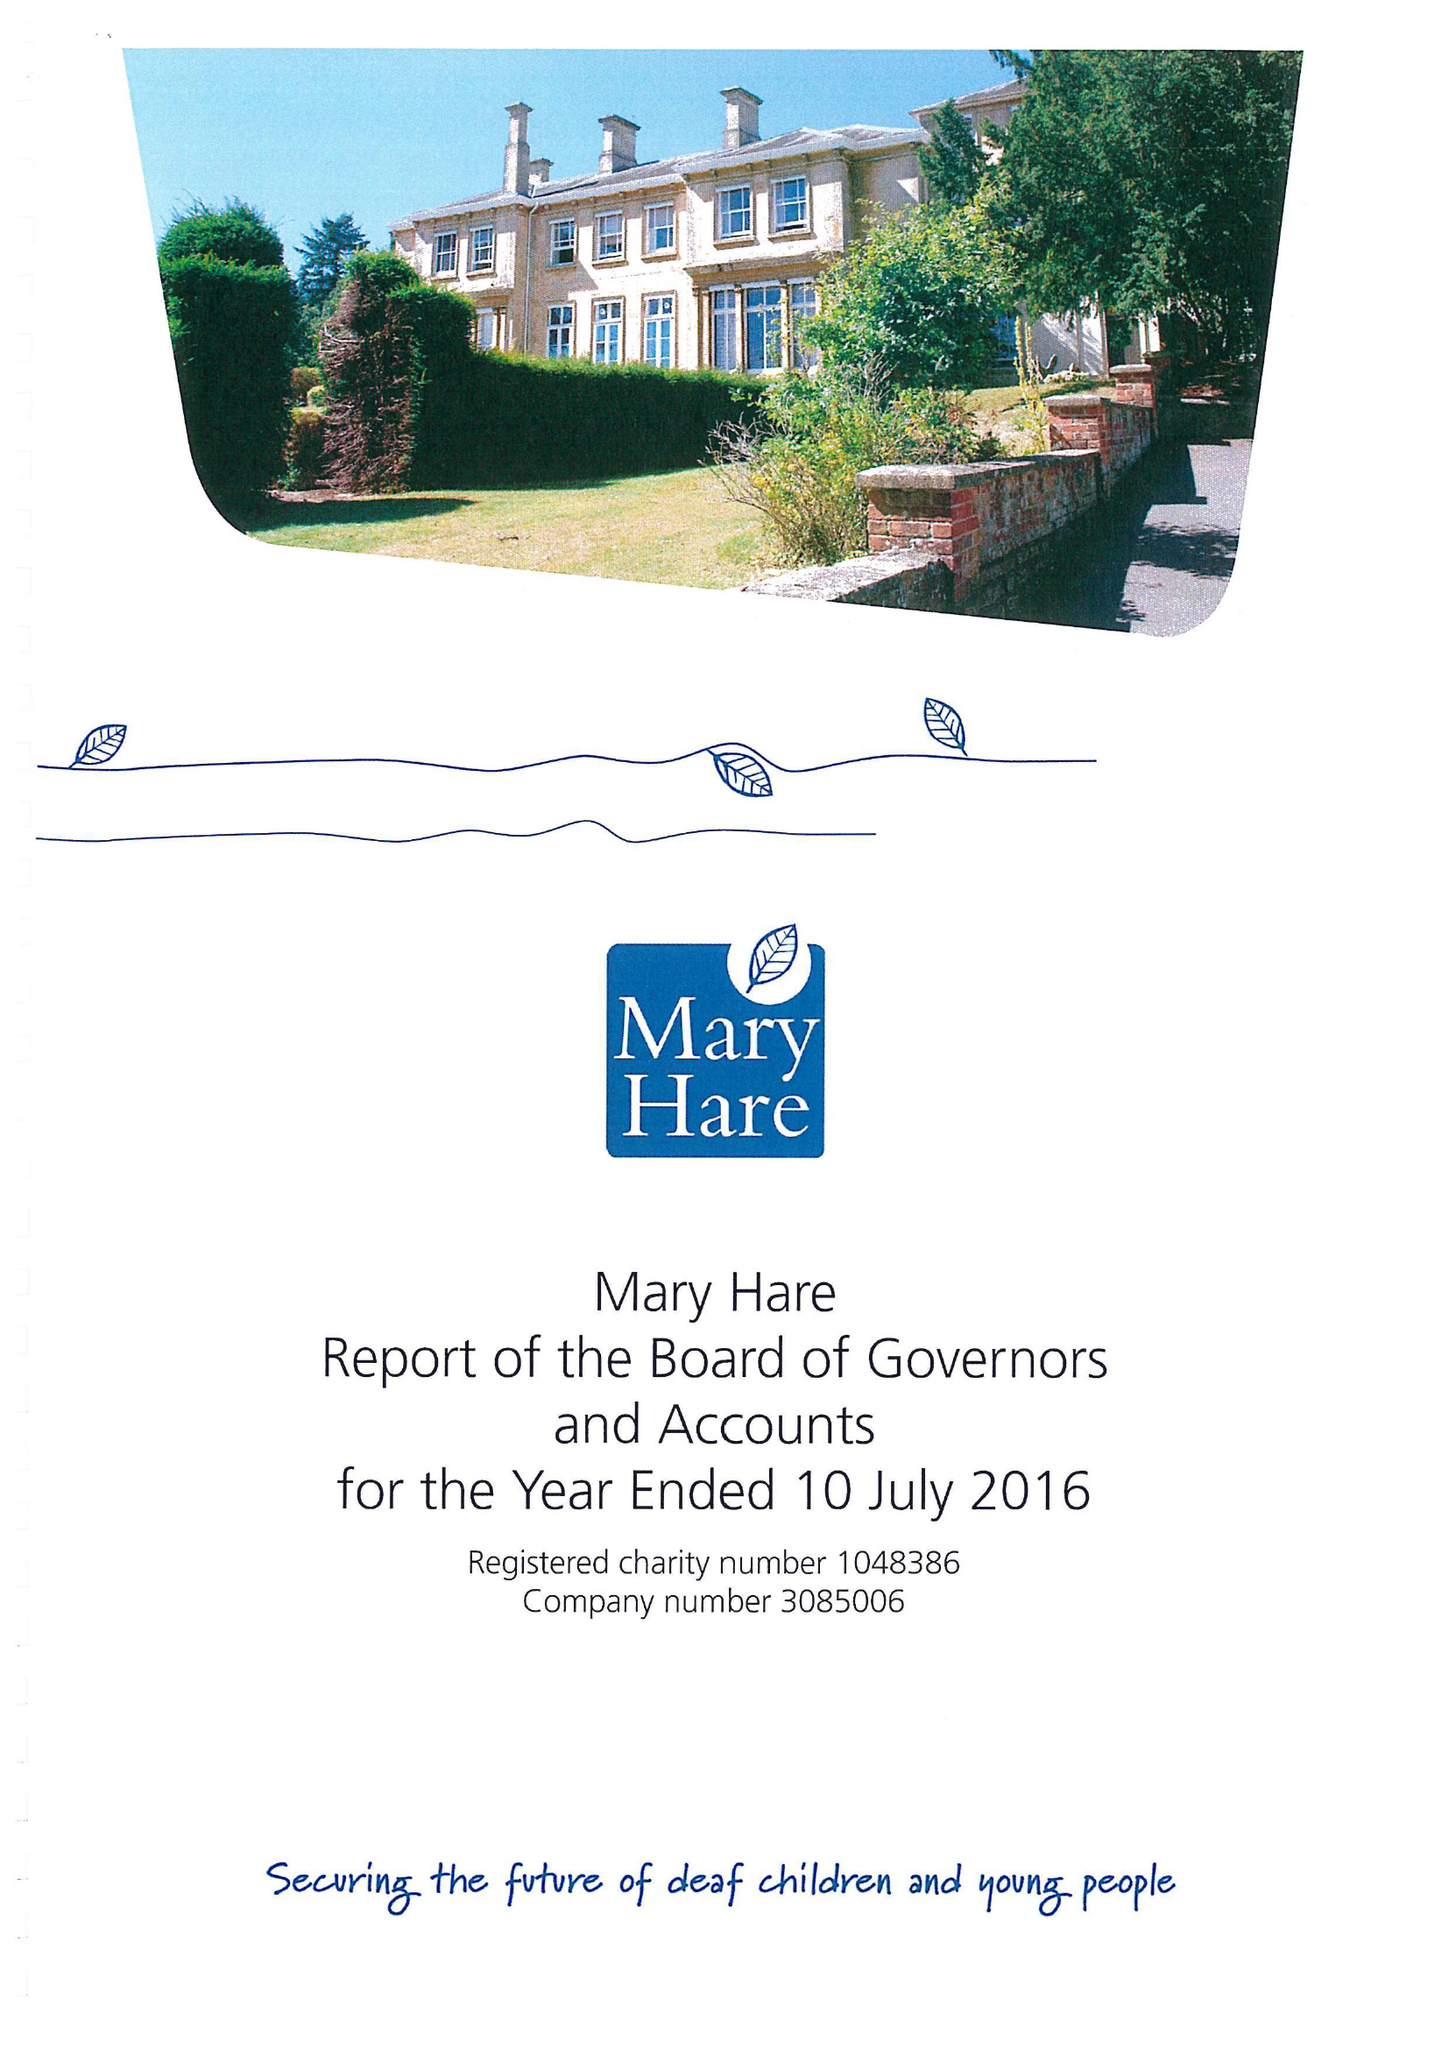What is the value for the charity_number?
Answer the question using a single word or phrase. 1048386 